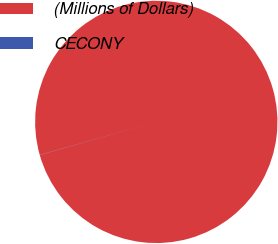Convert chart to OTSL. <chart><loc_0><loc_0><loc_500><loc_500><pie_chart><fcel>(Millions of Dollars)<fcel>CECONY<nl><fcel>99.98%<fcel>0.02%<nl></chart> 